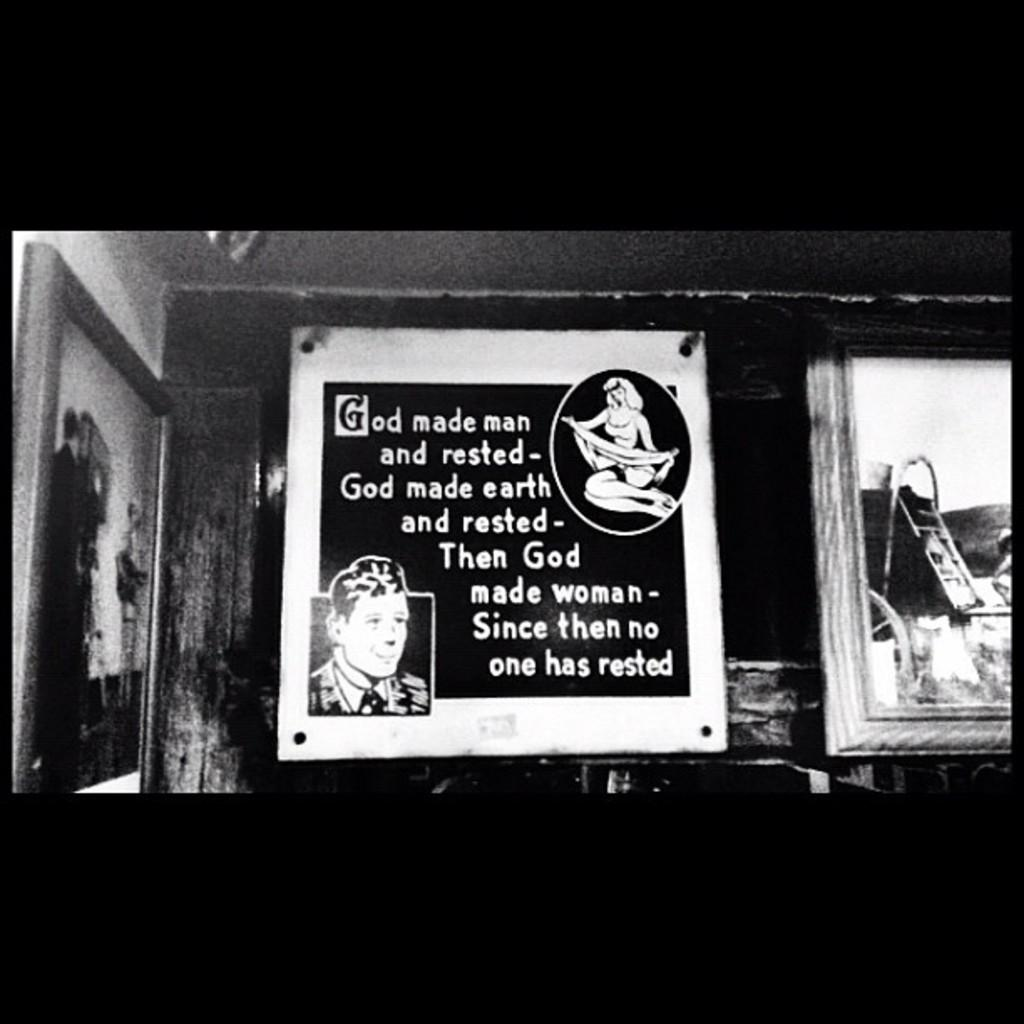<image>
Offer a succinct explanation of the picture presented. A black and white cartoon image with the punchline that "God made woman - since then no one has rested" 